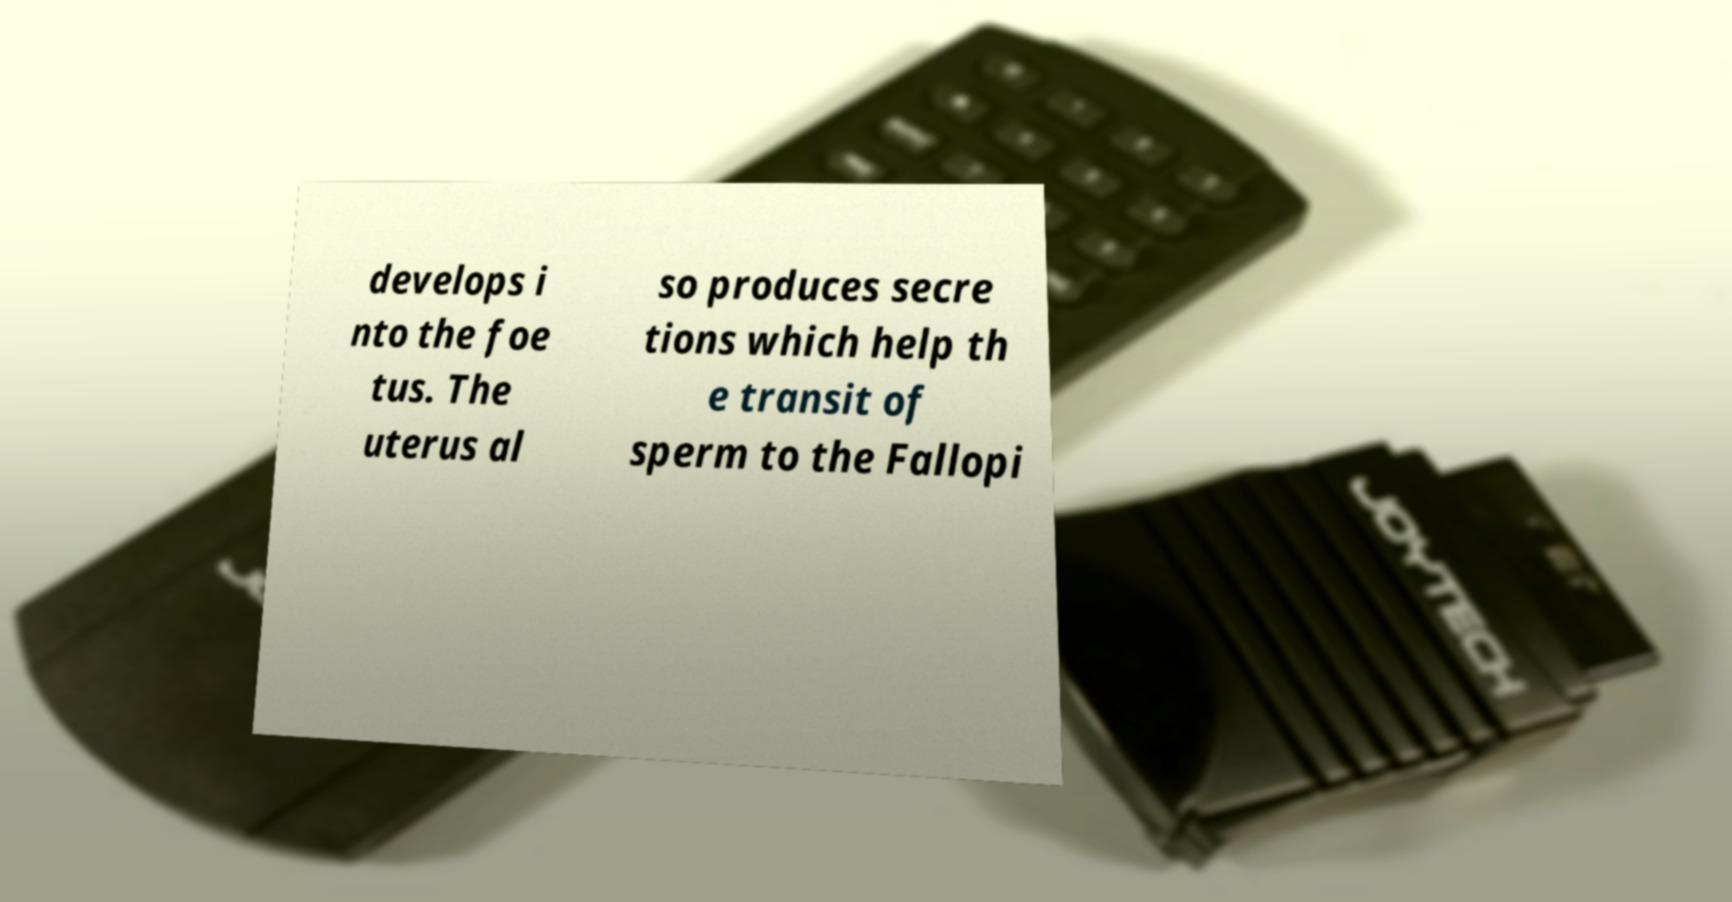Can you read and provide the text displayed in the image?This photo seems to have some interesting text. Can you extract and type it out for me? develops i nto the foe tus. The uterus al so produces secre tions which help th e transit of sperm to the Fallopi 